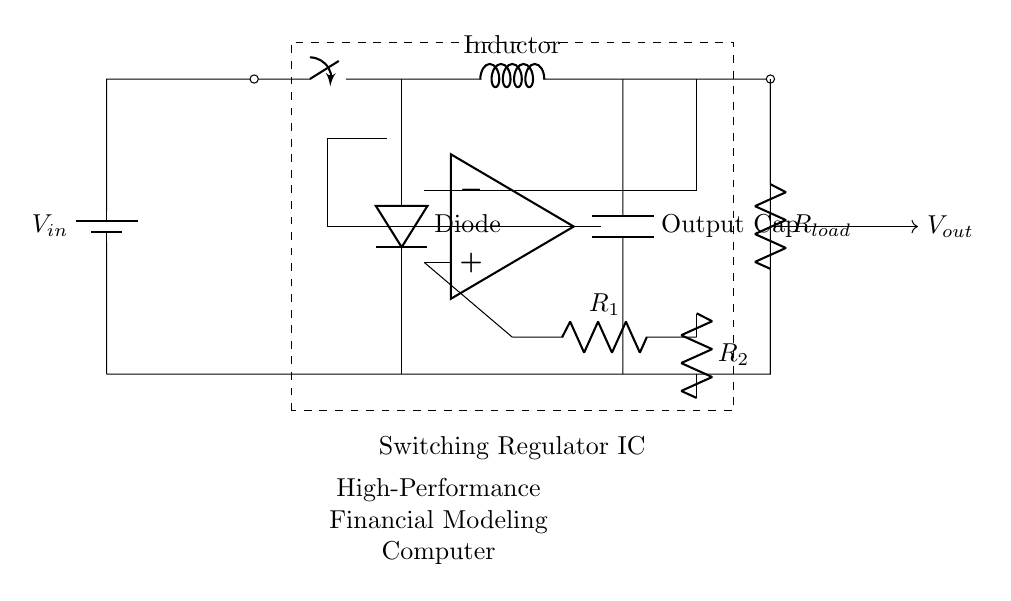What is the input voltage labeled in the circuit? The circuit diagram indicates that the input voltage is labeled as V_in, which represents the voltage supplied to the circuit.
Answer: V_in What type of component is placed at the output of the inductor? The output of the inductor is connected to a capacitor, labeled as Output Cap, which is used to smoothen the output voltage.
Answer: Capacitor What role does the diode play in this circuit? The diode, labeled as D, is used for allowing current to flow in one direction, preventing backflow, which is essential for maintaining the efficiency of the voltage regulation.
Answer: Allows current flow in one direction What is the purpose of the switching regulator IC in this circuit? The switching regulator IC is responsible for controlling the output voltage and ensuring efficient energy conversion from input to output by generating PWM signals to regulate the output.
Answer: Voltage control What are the resistance values labeled in the circuit? The circuit contains two resistors labeled as R_1 and R_2, with values that are typically chosen to set the gain of the voltage regulation. The exact values are not provided in the diagram but are critical for setting the desired output voltage.
Answer: R_1 and R_2 How does the inductor affect the overall performance of the regulator? The inductor smooths out the current and stores energy, which helps in transferring energy efficiently from the input to the output during the switching operation, thus contributing to the overall efficiency of the regulator.
Answer: Smooths current What type of load is represented at the output? The load at the output is labeled as R_load, indicating that it is a resistive load, which is typical in testing the output performance of voltage regulators.
Answer: Resistive load 